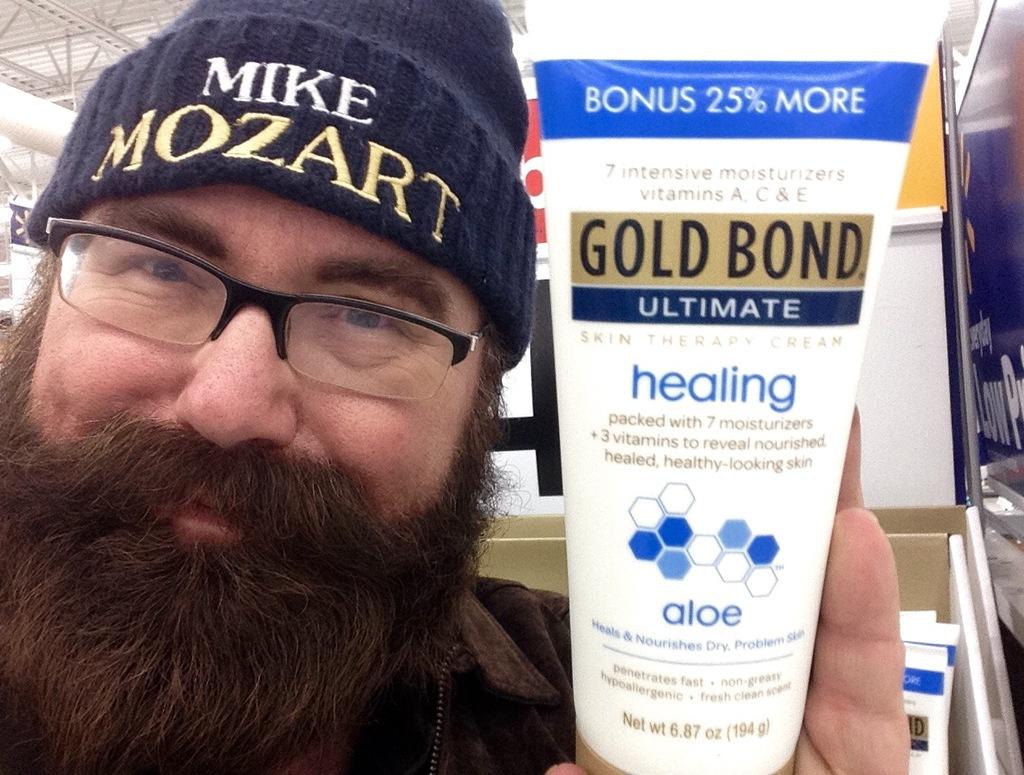What is the kind of lotion?
Offer a terse response. Gold bond. What does the man's hat say?
Your answer should be compact. Mike mozart. 